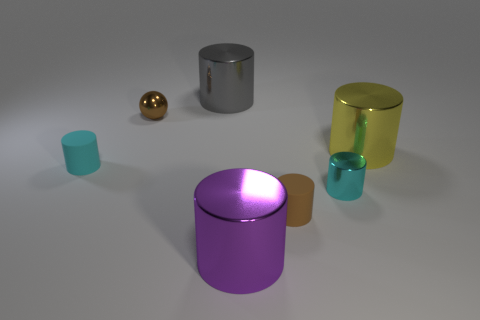Subtract all metallic cylinders. How many cylinders are left? 2 Subtract all yellow cylinders. How many cylinders are left? 5 Add 1 tiny red cylinders. How many objects exist? 8 Subtract all red cubes. How many cyan cylinders are left? 2 Subtract all cylinders. How many objects are left? 1 Subtract 4 cylinders. How many cylinders are left? 2 Subtract 0 blue cubes. How many objects are left? 7 Subtract all red balls. Subtract all red cylinders. How many balls are left? 1 Subtract all large purple cylinders. Subtract all large purple cylinders. How many objects are left? 5 Add 7 big purple things. How many big purple things are left? 8 